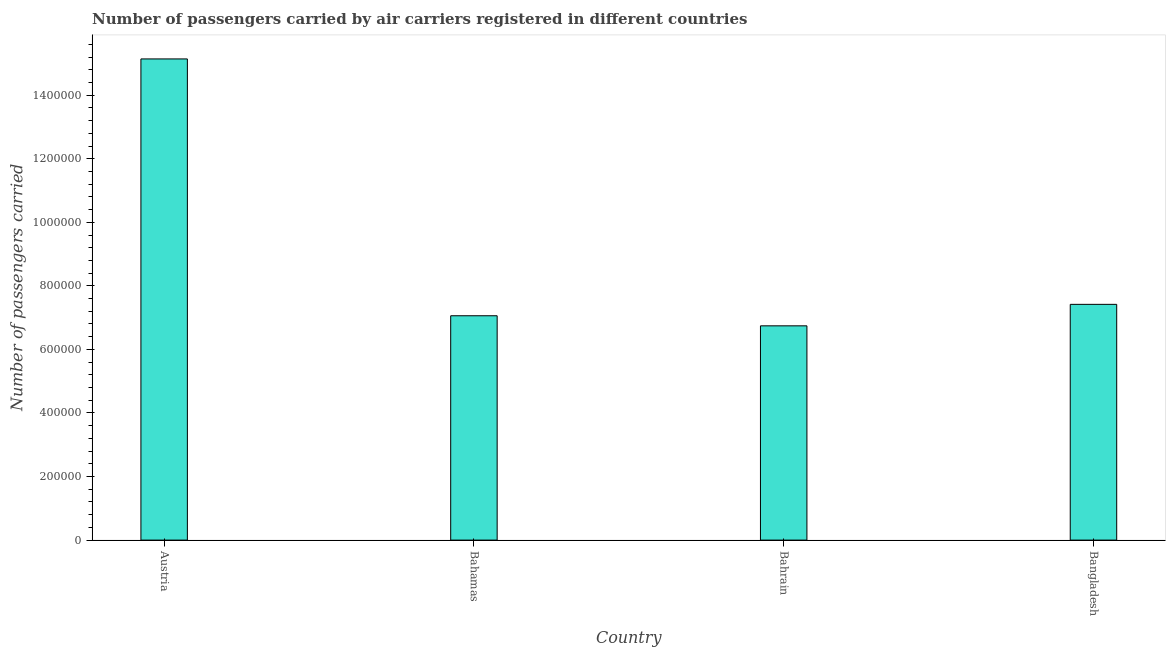What is the title of the graph?
Provide a short and direct response. Number of passengers carried by air carriers registered in different countries. What is the label or title of the Y-axis?
Keep it short and to the point. Number of passengers carried. What is the number of passengers carried in Austria?
Offer a very short reply. 1.51e+06. Across all countries, what is the maximum number of passengers carried?
Provide a succinct answer. 1.51e+06. Across all countries, what is the minimum number of passengers carried?
Provide a short and direct response. 6.74e+05. In which country was the number of passengers carried minimum?
Make the answer very short. Bahrain. What is the sum of the number of passengers carried?
Give a very brief answer. 3.64e+06. What is the difference between the number of passengers carried in Bahrain and Bangladesh?
Your answer should be very brief. -6.76e+04. What is the average number of passengers carried per country?
Provide a short and direct response. 9.09e+05. What is the median number of passengers carried?
Your answer should be very brief. 7.24e+05. What is the ratio of the number of passengers carried in Austria to that in Bahrain?
Offer a very short reply. 2.25. Is the difference between the number of passengers carried in Bahamas and Bahrain greater than the difference between any two countries?
Offer a very short reply. No. What is the difference between the highest and the second highest number of passengers carried?
Keep it short and to the point. 7.72e+05. Is the sum of the number of passengers carried in Austria and Bahamas greater than the maximum number of passengers carried across all countries?
Your response must be concise. Yes. What is the difference between the highest and the lowest number of passengers carried?
Provide a succinct answer. 8.40e+05. How many bars are there?
Provide a succinct answer. 4. What is the Number of passengers carried of Austria?
Your response must be concise. 1.51e+06. What is the Number of passengers carried in Bahamas?
Provide a succinct answer. 7.06e+05. What is the Number of passengers carried in Bahrain?
Your response must be concise. 6.74e+05. What is the Number of passengers carried of Bangladesh?
Your response must be concise. 7.42e+05. What is the difference between the Number of passengers carried in Austria and Bahamas?
Ensure brevity in your answer.  8.08e+05. What is the difference between the Number of passengers carried in Austria and Bahrain?
Keep it short and to the point. 8.40e+05. What is the difference between the Number of passengers carried in Austria and Bangladesh?
Offer a very short reply. 7.72e+05. What is the difference between the Number of passengers carried in Bahamas and Bahrain?
Your answer should be compact. 3.17e+04. What is the difference between the Number of passengers carried in Bahamas and Bangladesh?
Offer a very short reply. -3.59e+04. What is the difference between the Number of passengers carried in Bahrain and Bangladesh?
Ensure brevity in your answer.  -6.76e+04. What is the ratio of the Number of passengers carried in Austria to that in Bahamas?
Offer a very short reply. 2.15. What is the ratio of the Number of passengers carried in Austria to that in Bahrain?
Offer a terse response. 2.25. What is the ratio of the Number of passengers carried in Austria to that in Bangladesh?
Provide a short and direct response. 2.04. What is the ratio of the Number of passengers carried in Bahamas to that in Bahrain?
Offer a very short reply. 1.05. What is the ratio of the Number of passengers carried in Bahamas to that in Bangladesh?
Your response must be concise. 0.95. What is the ratio of the Number of passengers carried in Bahrain to that in Bangladesh?
Your answer should be very brief. 0.91. 